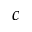Convert formula to latex. <formula><loc_0><loc_0><loc_500><loc_500>c</formula> 